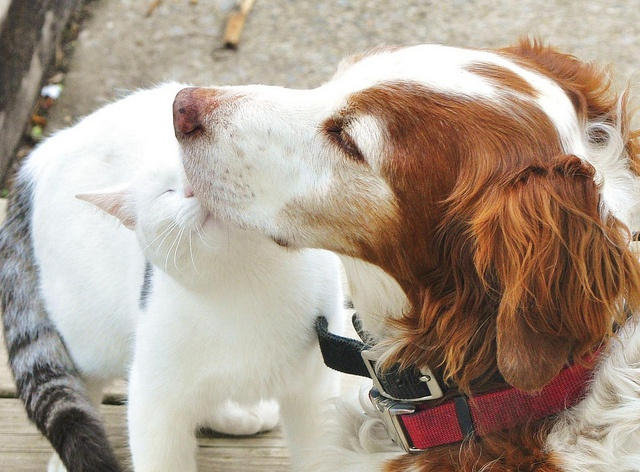Describe the objects in this image and their specific colors. I can see dog in lightgray, maroon, brown, and gray tones and cat in lightgray and darkgray tones in this image. 